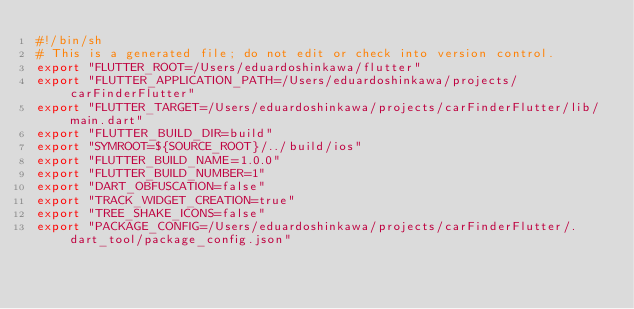Convert code to text. <code><loc_0><loc_0><loc_500><loc_500><_Bash_>#!/bin/sh
# This is a generated file; do not edit or check into version control.
export "FLUTTER_ROOT=/Users/eduardoshinkawa/flutter"
export "FLUTTER_APPLICATION_PATH=/Users/eduardoshinkawa/projects/carFinderFlutter"
export "FLUTTER_TARGET=/Users/eduardoshinkawa/projects/carFinderFlutter/lib/main.dart"
export "FLUTTER_BUILD_DIR=build"
export "SYMROOT=${SOURCE_ROOT}/../build/ios"
export "FLUTTER_BUILD_NAME=1.0.0"
export "FLUTTER_BUILD_NUMBER=1"
export "DART_OBFUSCATION=false"
export "TRACK_WIDGET_CREATION=true"
export "TREE_SHAKE_ICONS=false"
export "PACKAGE_CONFIG=/Users/eduardoshinkawa/projects/carFinderFlutter/.dart_tool/package_config.json"
</code> 